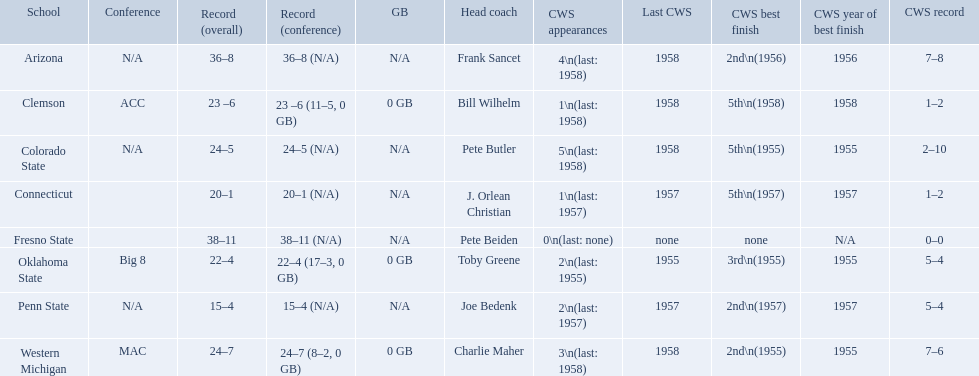How many cws appearances does clemson have? 1\n(last: 1958). How many cws appearances does western michigan have? 3\n(last: 1958). Which of these schools has more cws appearances? Western Michigan. 